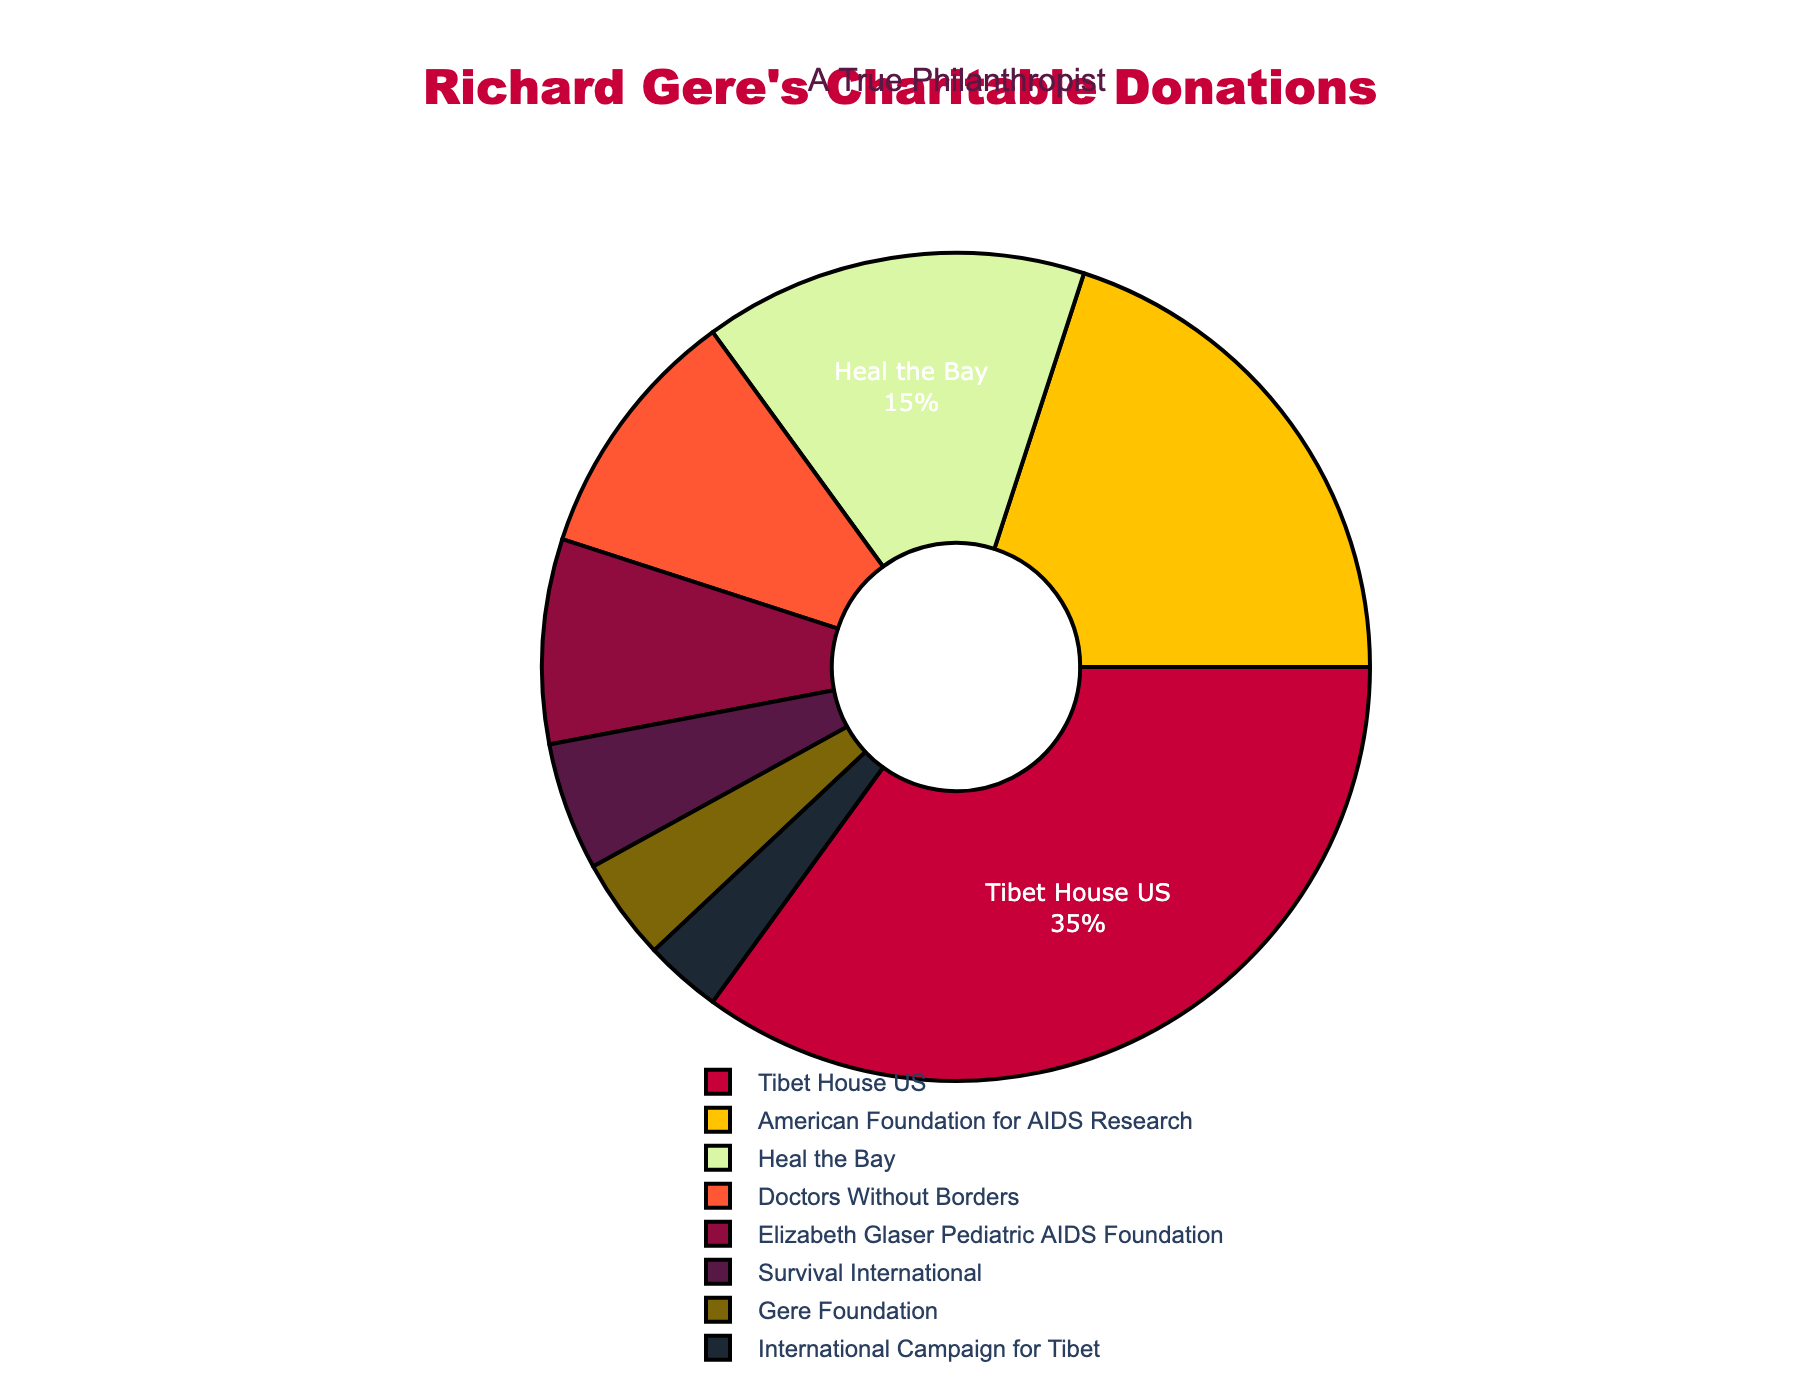Which cause gets the largest share of Richard Gere's charitable donations? The cause with the largest percentage on the pie chart is "Tibet House US" at 35%.
Answer: Tibet House US Which two causes combined receive 30% of the donations? "American Foundation for AIDS Research" at 20% plus "Heal the Bay" at 15% amounts to 35%, but two smaller causes, "Doctors Without Borders" (10%) and "Elizabeth Glaser Pediatric AIDS Foundation" (8%) combine to give 18%. If we go further down the list, "Survival International" (5%) and "Gere Foundation" (4%) sum to 9%, and finally, "Gere Foundation" (4%) plus "International Campaign for Tibet" (3%) sum to 7%. For simplicity and accuracy, “Heal the Bay” and "Doctors Without Borders" combined together make 25%.
Answer: Heal the Bay, Doctors Without Borders Which causes each get a donation percentage that is less than 10? The causes with a percentage less than 10% are: "Doctors Without Borders" (10%), "Elizabeth Glaser Pediatric AIDS Foundation" (8%), "Survival International" (5%), "Gere Foundation" (4%), and "International Campaign for Tibet" (3%).
Answer: Elizabeth Glaser Pediatric AIDS Foundation, Survival International, Gere Foundation, International Campaign for Tibet What is the total percentage of donations dedicated to AIDS-related causes? Summing up the percentages for "American Foundation for AIDS Research" (20%) and "Elizabeth Glaser Pediatric AIDS Foundation" (8%) gives a total of 20% + 8% = 28%.
Answer: 28% Which cause receives the smallest percentage of donations and what percentage is it? The cause with the smallest percentage on the pie chart is the "International Campaign for Tibet" at 3%.
Answer: International Campaign for Tibet, 3% What is the difference in donation percentage between "Tibet House US" and the "American Foundation for AIDS Research"? "Tibet House US" receives 35% and "American Foundation for AIDS Research" receives 20%. The difference is 35% - 20% = 15%.
Answer: 15% Which causes receive equal or less than 5% of the donations each? The causes that receive equal to or less than 5% are "Survival International" at 5%, "Gere Foundation" at 4%, and "International Campaign for Tibet" at 3%.
Answer: Survival International, Gere Foundation, International Campaign for Tibet How much more percentage does "Tibet House US" receive compared to "Heal the Bay"? "Tibet House US" receives 35% and "Heal the Bay" receives 15%. The difference is 35% - 15% = 20%.
Answer: 20% Which cause, among all, gets the median percentage of donations? Arranging the percentages in ascending order: 3%, 4%, 5%, 8%, 10%, 15%, 20%, 35%. The median percentages fall between 10% and 15%, hence the cause with the median percentage is "Heal the Bay" at 15%.
Answer: Heal the Bay What is the combined percentage of donations given to environmental causes? The environmental causes are "Heal the Bay" (15%) and "Survival International" (5%). The combined percentage is 15% + 5% = 20%.
Answer: 20% 